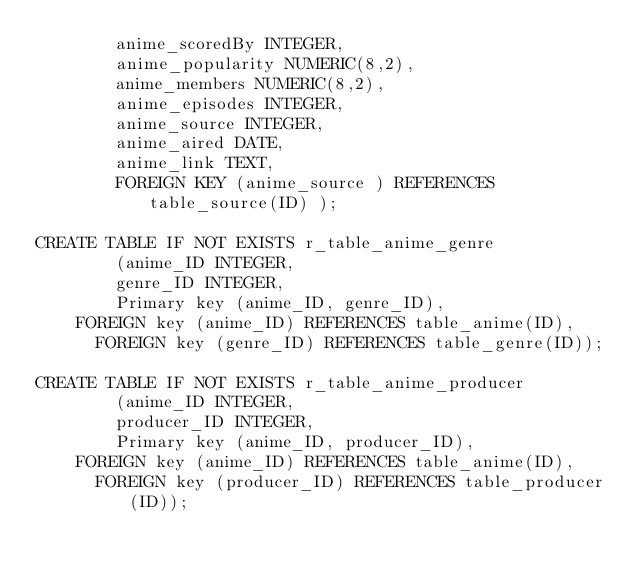Convert code to text. <code><loc_0><loc_0><loc_500><loc_500><_SQL_>        anime_scoredBy INTEGER,
        anime_popularity NUMERIC(8,2),
        anime_members NUMERIC(8,2),
        anime_episodes INTEGER,
        anime_source INTEGER,
        anime_aired DATE,
        anime_link TEXT,
        FOREIGN KEY (anime_source ) REFERENCES table_source(ID) );

CREATE TABLE IF NOT EXISTS r_table_anime_genre
        (anime_ID INTEGER,
        genre_ID INTEGER,
        Primary key (anime_ID, genre_ID),
		FOREIGN key (anime_ID) REFERENCES table_anime(ID),
	    FOREIGN key (genre_ID) REFERENCES table_genre(ID));

CREATE TABLE IF NOT EXISTS r_table_anime_producer
        (anime_ID INTEGER,
        producer_ID INTEGER,
        Primary key (anime_ID, producer_ID),
		FOREIGN key (anime_ID) REFERENCES table_anime(ID),
	    FOREIGN key (producer_ID) REFERENCES table_producer(ID));</code> 